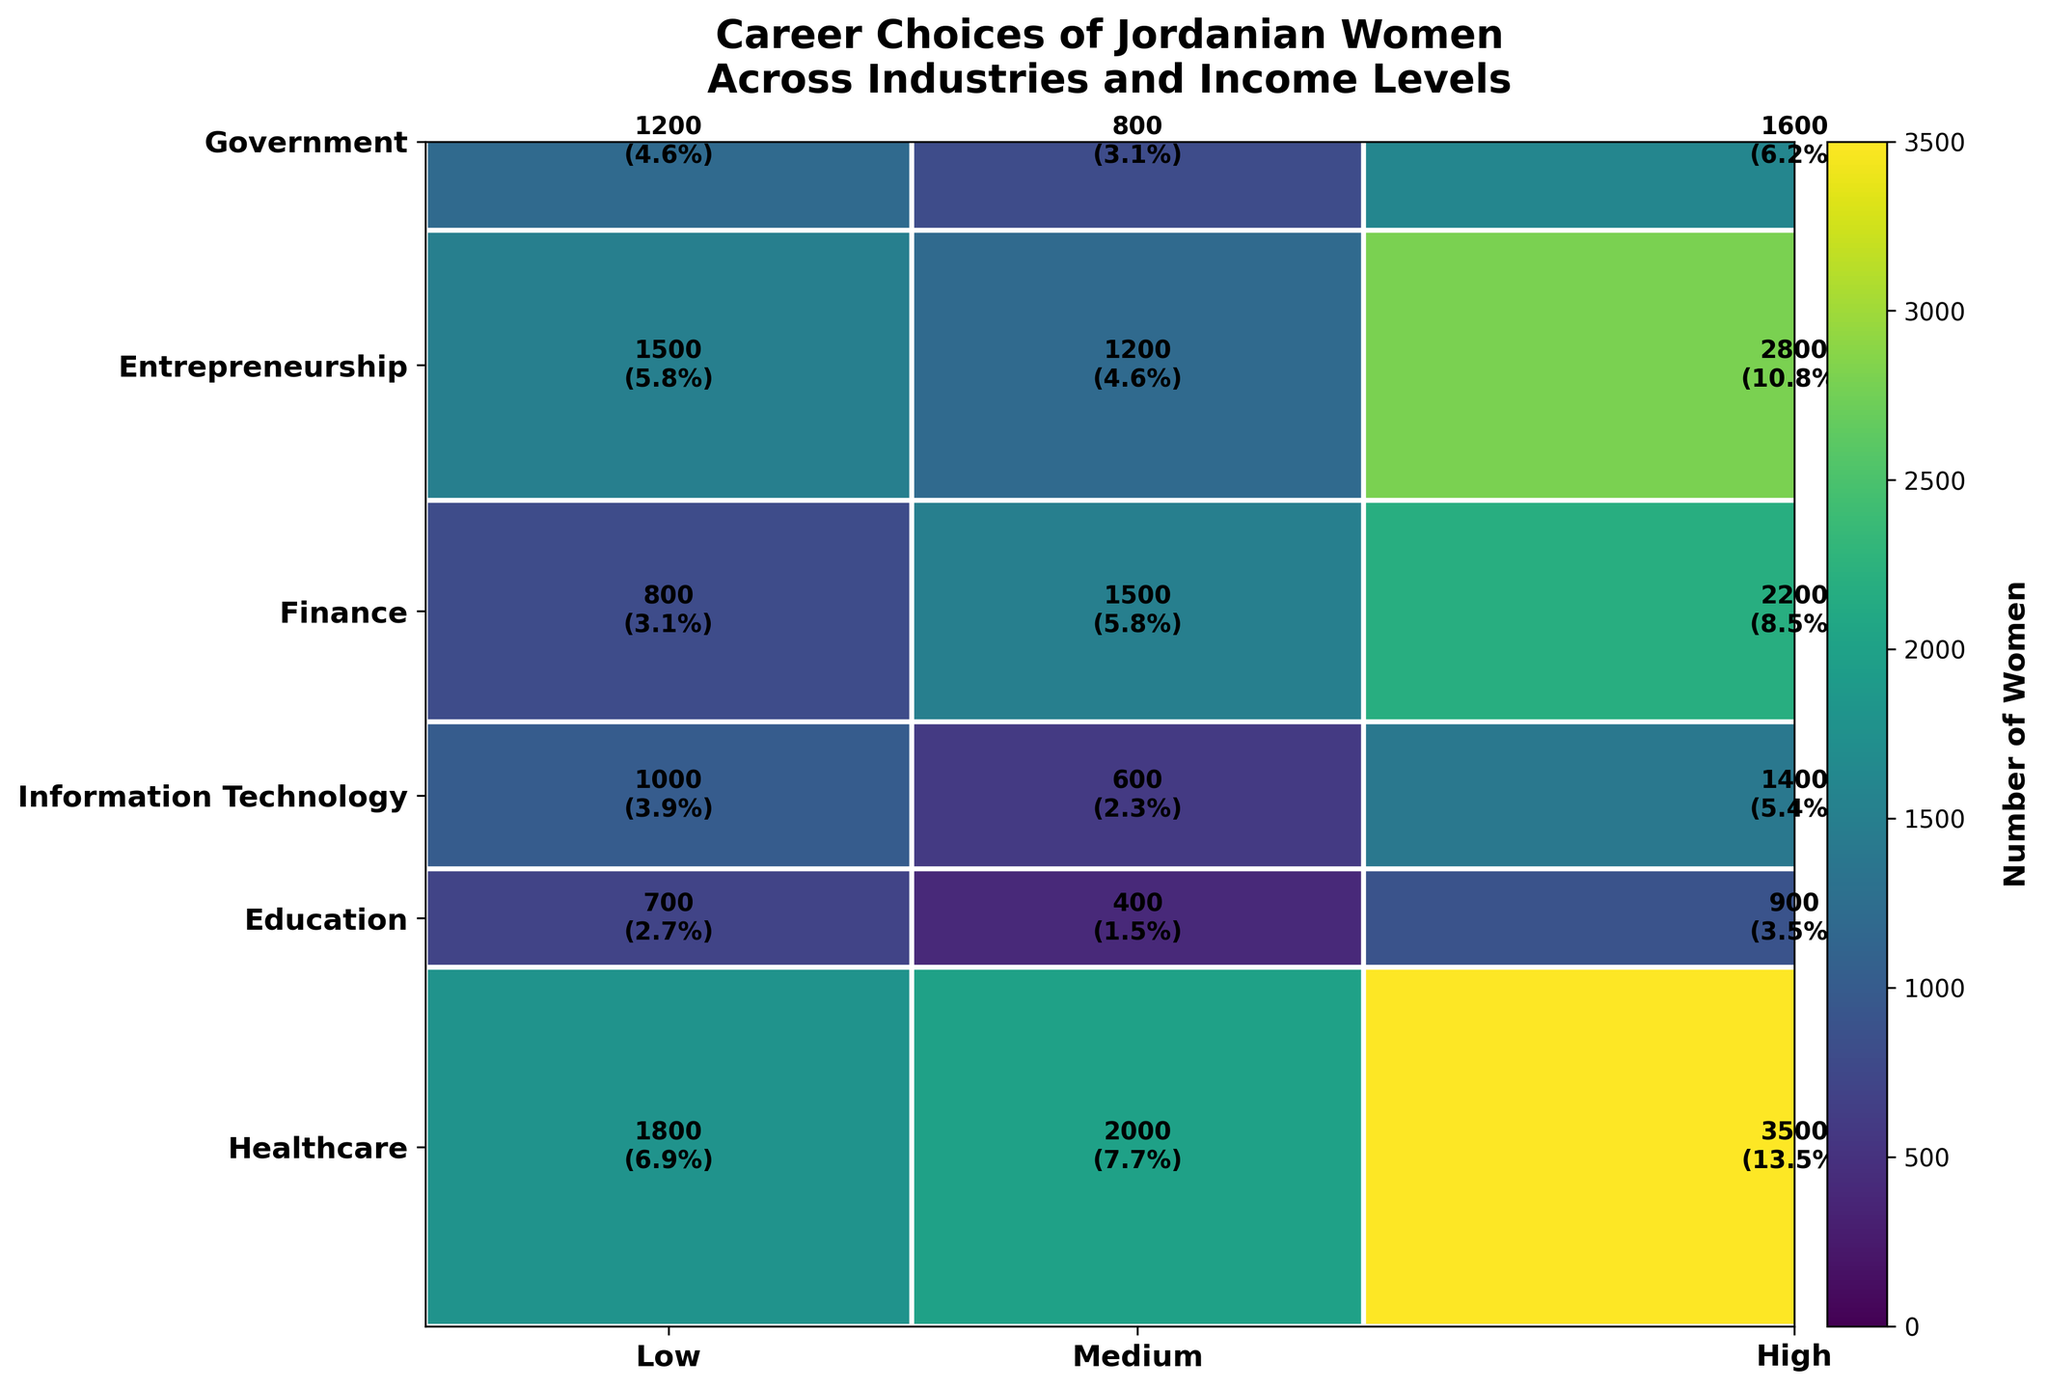What's the most common industry for Jordanian women with medium income levels? To determine this, look at the medium column and identify the industry with the largest area (or number) in this section. Education has the largest area and text indicating 3500 women.
Answer: Education Which industry has the least number of women in the high-income level? Check the high-income column and identify the smallest segment. Entrepreneurship has the smallest area with 700 women.
Answer: Entrepreneurship How many Jordanian women work in Finance at any income level? Sum the number of women in the Finance industry across all income levels. Here, it is 600 (Low) + 1400 (Medium) + 1000 (High) = 3000.
Answer: 3000 What's the percentage of Jordanian women working in Healthcare, out of the total number of women in all industries? First, sum up the number of women in Healthcare for all income levels which is 1200 (Low) + 2800 (Medium) + 1500 (High) = 5500. Then, sum the total number of women in all industries: 5500 (Healthcare) + 7300 (Education) + 3600 (Information Technology) + 3000 (Finance) + 2000 (Entrepreneurship) + 4500 (Government) = 25900. The percentage is (5500/25900) * 100 ≈ 21.2%.
Answer: 21.2% Which industry has the highest number of women in the low-income level? Look at the low-income column and find the largest segment. Education has the largest area with 2000 women.
Answer: Education Compare the number of women in Information Technology and Education at the high-income level. Which is higher? Referring to the high-income sections, Information Technology has 1200 women and Education has 1800 women. Education has a higher number.
Answer: Education Are there more women in Government or Entrepreneurship across all income levels? Sum the number of women across all income levels for both industries. Government: 1500 (Low) + 2200 (Medium) + 800 (High) = 4500. Entrepreneurship: 400 (Low) + 900 (Medium) + 700 (High) = 2000. Government has more women.
Answer: Government What's the total number of women in the Government industry? Add the number of women in the Government industry across all income levels: 1500 (Low) + 2200 (Medium) + 800 (High) = 4500.
Answer: 4500 